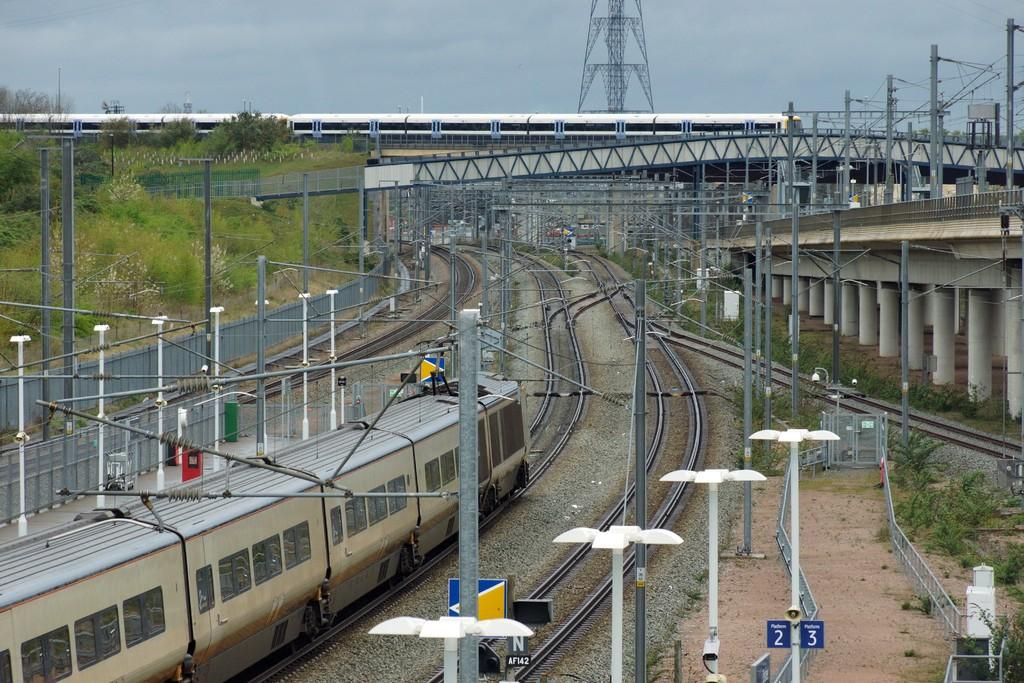<image>
Render a clear and concise summary of the photo. Train tracks with a train on it and a sign that has a N on it. 